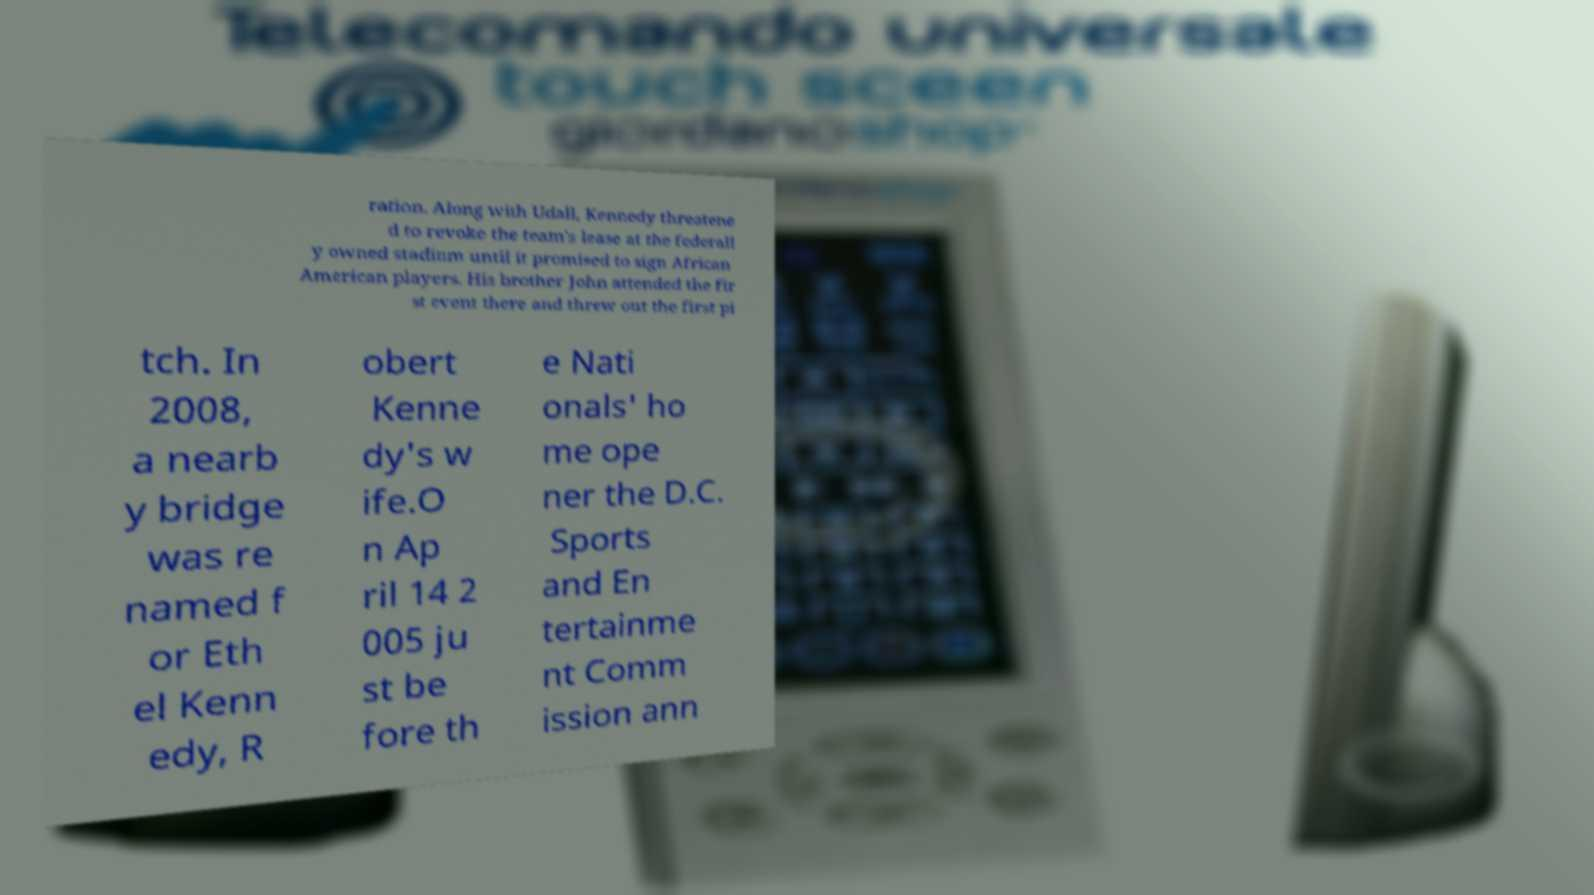Could you assist in decoding the text presented in this image and type it out clearly? ration. Along with Udall, Kennedy threatene d to revoke the team's lease at the federall y owned stadium until it promised to sign African American players. His brother John attended the fir st event there and threw out the first pi tch. In 2008, a nearb y bridge was re named f or Eth el Kenn edy, R obert Kenne dy's w ife.O n Ap ril 14 2 005 ju st be fore th e Nati onals' ho me ope ner the D.C. Sports and En tertainme nt Comm ission ann 